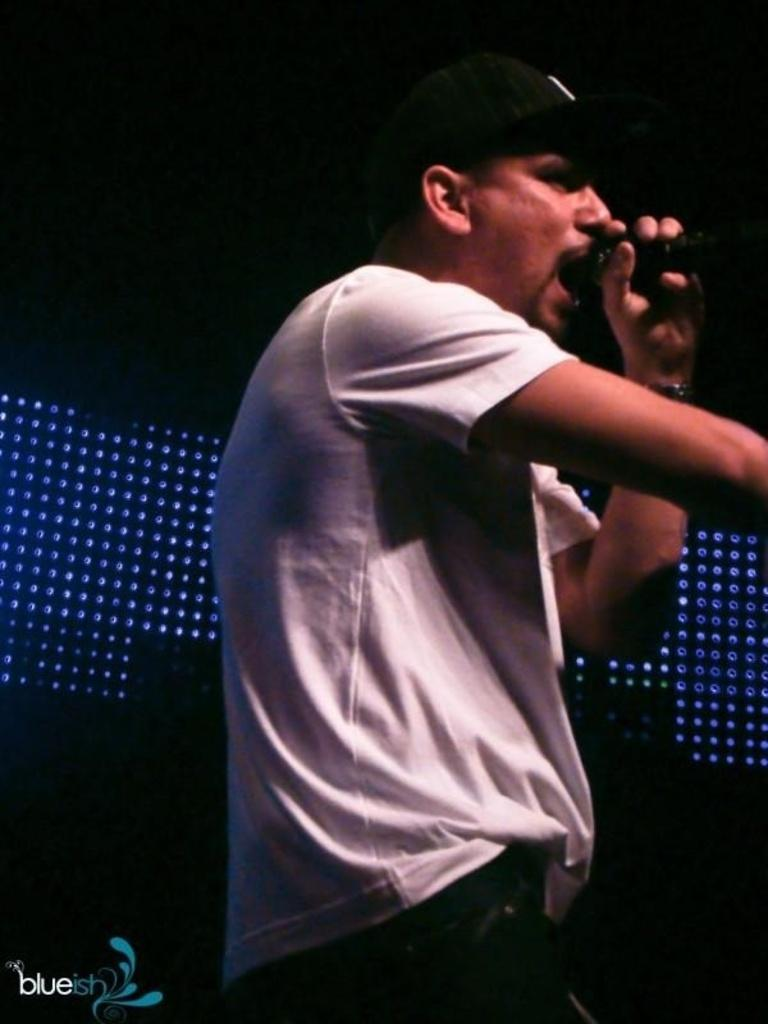What is the man in the image doing? The man is holding a microphone and singing a song. What is the man holding while singing? The man is holding a microphone. What can be seen in the background of the image? There is a dark background in the image. What is visible in the image besides the man and the microphone? There are lights visible in the image. Is there any additional information about the image? Yes, there is a watermark on the image. How many children are playing with books in the image? There are no children or books present in the image. What type of jump is the man performing in the image? The man is not jumping in the image; he is singing while holding a microphone. 